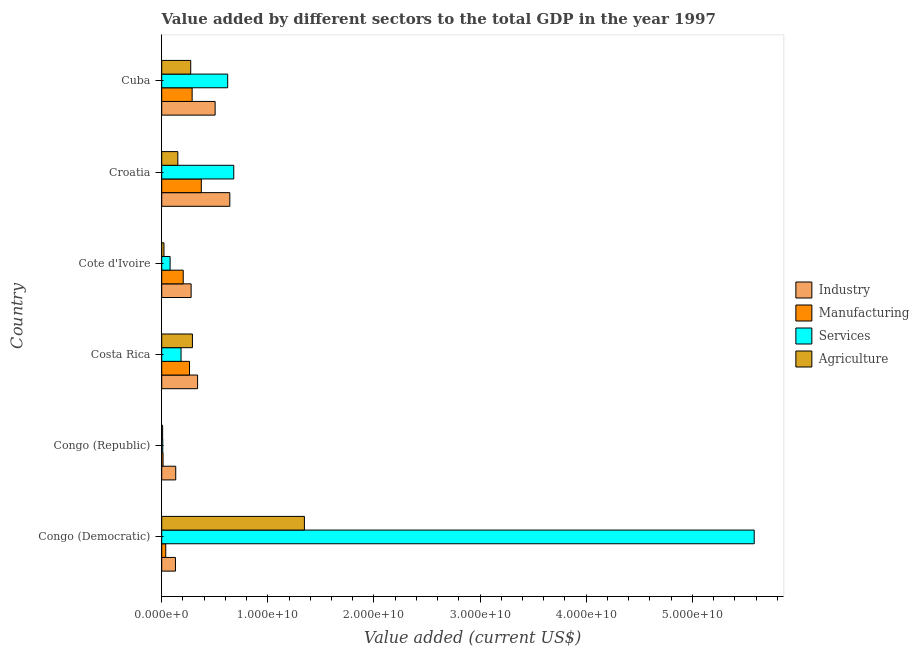How many groups of bars are there?
Give a very brief answer. 6. Are the number of bars per tick equal to the number of legend labels?
Make the answer very short. Yes. What is the label of the 2nd group of bars from the top?
Make the answer very short. Croatia. What is the value added by agricultural sector in Costa Rica?
Your answer should be compact. 2.89e+09. Across all countries, what is the maximum value added by agricultural sector?
Your response must be concise. 1.34e+1. Across all countries, what is the minimum value added by manufacturing sector?
Give a very brief answer. 1.27e+08. In which country was the value added by services sector maximum?
Give a very brief answer. Congo (Democratic). In which country was the value added by agricultural sector minimum?
Offer a terse response. Congo (Republic). What is the total value added by agricultural sector in the graph?
Make the answer very short. 2.09e+1. What is the difference between the value added by services sector in Congo (Republic) and that in Cuba?
Your answer should be compact. -6.12e+09. What is the difference between the value added by agricultural sector in Congo (Democratic) and the value added by manufacturing sector in Congo (Republic)?
Make the answer very short. 1.33e+1. What is the average value added by manufacturing sector per country?
Your response must be concise. 1.96e+09. What is the difference between the value added by agricultural sector and value added by services sector in Congo (Democratic)?
Your response must be concise. -4.24e+1. What is the ratio of the value added by industrial sector in Congo (Democratic) to that in Costa Rica?
Make the answer very short. 0.38. Is the value added by manufacturing sector in Congo (Democratic) less than that in Costa Rica?
Offer a terse response. Yes. Is the difference between the value added by industrial sector in Congo (Democratic) and Cuba greater than the difference between the value added by services sector in Congo (Democratic) and Cuba?
Keep it short and to the point. No. What is the difference between the highest and the second highest value added by industrial sector?
Make the answer very short. 1.38e+09. What is the difference between the highest and the lowest value added by agricultural sector?
Provide a succinct answer. 1.34e+1. In how many countries, is the value added by services sector greater than the average value added by services sector taken over all countries?
Provide a short and direct response. 1. Is the sum of the value added by services sector in Congo (Democratic) and Cote d'Ivoire greater than the maximum value added by manufacturing sector across all countries?
Provide a short and direct response. Yes. Is it the case that in every country, the sum of the value added by services sector and value added by agricultural sector is greater than the sum of value added by manufacturing sector and value added by industrial sector?
Keep it short and to the point. No. What does the 2nd bar from the top in Cote d'Ivoire represents?
Your answer should be compact. Services. What does the 3rd bar from the bottom in Costa Rica represents?
Give a very brief answer. Services. Does the graph contain any zero values?
Offer a very short reply. No. Does the graph contain grids?
Offer a terse response. No. Where does the legend appear in the graph?
Keep it short and to the point. Center right. What is the title of the graph?
Provide a short and direct response. Value added by different sectors to the total GDP in the year 1997. What is the label or title of the X-axis?
Your response must be concise. Value added (current US$). What is the Value added (current US$) of Industry in Congo (Democratic)?
Ensure brevity in your answer.  1.29e+09. What is the Value added (current US$) in Manufacturing in Congo (Democratic)?
Your answer should be very brief. 3.81e+08. What is the Value added (current US$) of Services in Congo (Democratic)?
Your answer should be very brief. 5.58e+1. What is the Value added (current US$) of Agriculture in Congo (Democratic)?
Keep it short and to the point. 1.34e+1. What is the Value added (current US$) of Industry in Congo (Republic)?
Keep it short and to the point. 1.32e+09. What is the Value added (current US$) in Manufacturing in Congo (Republic)?
Give a very brief answer. 1.27e+08. What is the Value added (current US$) in Services in Congo (Republic)?
Your answer should be very brief. 1.00e+08. What is the Value added (current US$) in Agriculture in Congo (Republic)?
Your answer should be compact. 8.67e+07. What is the Value added (current US$) of Industry in Costa Rica?
Keep it short and to the point. 3.38e+09. What is the Value added (current US$) in Manufacturing in Costa Rica?
Ensure brevity in your answer.  2.62e+09. What is the Value added (current US$) of Services in Costa Rica?
Offer a terse response. 1.82e+09. What is the Value added (current US$) of Agriculture in Costa Rica?
Give a very brief answer. 2.89e+09. What is the Value added (current US$) in Industry in Cote d'Ivoire?
Ensure brevity in your answer.  2.77e+09. What is the Value added (current US$) of Manufacturing in Cote d'Ivoire?
Your answer should be compact. 2.03e+09. What is the Value added (current US$) in Services in Cote d'Ivoire?
Your response must be concise. 7.90e+08. What is the Value added (current US$) in Agriculture in Cote d'Ivoire?
Provide a short and direct response. 2.12e+08. What is the Value added (current US$) of Industry in Croatia?
Offer a very short reply. 6.42e+09. What is the Value added (current US$) in Manufacturing in Croatia?
Your answer should be very brief. 3.73e+09. What is the Value added (current US$) in Services in Croatia?
Ensure brevity in your answer.  6.79e+09. What is the Value added (current US$) in Agriculture in Croatia?
Offer a very short reply. 1.52e+09. What is the Value added (current US$) in Industry in Cuba?
Make the answer very short. 5.03e+09. What is the Value added (current US$) in Manufacturing in Cuba?
Your answer should be compact. 2.87e+09. What is the Value added (current US$) in Services in Cuba?
Your answer should be compact. 6.22e+09. What is the Value added (current US$) of Agriculture in Cuba?
Keep it short and to the point. 2.73e+09. Across all countries, what is the maximum Value added (current US$) in Industry?
Give a very brief answer. 6.42e+09. Across all countries, what is the maximum Value added (current US$) of Manufacturing?
Offer a terse response. 3.73e+09. Across all countries, what is the maximum Value added (current US$) in Services?
Ensure brevity in your answer.  5.58e+1. Across all countries, what is the maximum Value added (current US$) in Agriculture?
Provide a succinct answer. 1.34e+1. Across all countries, what is the minimum Value added (current US$) of Industry?
Provide a succinct answer. 1.29e+09. Across all countries, what is the minimum Value added (current US$) of Manufacturing?
Provide a short and direct response. 1.27e+08. Across all countries, what is the minimum Value added (current US$) of Services?
Provide a succinct answer. 1.00e+08. Across all countries, what is the minimum Value added (current US$) in Agriculture?
Provide a short and direct response. 8.67e+07. What is the total Value added (current US$) in Industry in the graph?
Give a very brief answer. 2.02e+1. What is the total Value added (current US$) in Manufacturing in the graph?
Keep it short and to the point. 1.18e+1. What is the total Value added (current US$) of Services in the graph?
Provide a short and direct response. 7.15e+1. What is the total Value added (current US$) in Agriculture in the graph?
Your answer should be very brief. 2.09e+1. What is the difference between the Value added (current US$) in Industry in Congo (Democratic) and that in Congo (Republic)?
Keep it short and to the point. -2.64e+07. What is the difference between the Value added (current US$) of Manufacturing in Congo (Democratic) and that in Congo (Republic)?
Keep it short and to the point. 2.54e+08. What is the difference between the Value added (current US$) in Services in Congo (Democratic) and that in Congo (Republic)?
Provide a succinct answer. 5.57e+1. What is the difference between the Value added (current US$) in Agriculture in Congo (Democratic) and that in Congo (Republic)?
Your response must be concise. 1.34e+1. What is the difference between the Value added (current US$) of Industry in Congo (Democratic) and that in Costa Rica?
Give a very brief answer. -2.09e+09. What is the difference between the Value added (current US$) in Manufacturing in Congo (Democratic) and that in Costa Rica?
Provide a succinct answer. -2.24e+09. What is the difference between the Value added (current US$) in Services in Congo (Democratic) and that in Costa Rica?
Your answer should be compact. 5.40e+1. What is the difference between the Value added (current US$) of Agriculture in Congo (Democratic) and that in Costa Rica?
Ensure brevity in your answer.  1.06e+1. What is the difference between the Value added (current US$) of Industry in Congo (Democratic) and that in Cote d'Ivoire?
Provide a short and direct response. -1.48e+09. What is the difference between the Value added (current US$) in Manufacturing in Congo (Democratic) and that in Cote d'Ivoire?
Your answer should be very brief. -1.65e+09. What is the difference between the Value added (current US$) in Services in Congo (Democratic) and that in Cote d'Ivoire?
Your answer should be very brief. 5.50e+1. What is the difference between the Value added (current US$) of Agriculture in Congo (Democratic) and that in Cote d'Ivoire?
Your response must be concise. 1.32e+1. What is the difference between the Value added (current US$) in Industry in Congo (Democratic) and that in Croatia?
Your response must be concise. -5.12e+09. What is the difference between the Value added (current US$) of Manufacturing in Congo (Democratic) and that in Croatia?
Offer a terse response. -3.35e+09. What is the difference between the Value added (current US$) of Services in Congo (Democratic) and that in Croatia?
Ensure brevity in your answer.  4.90e+1. What is the difference between the Value added (current US$) of Agriculture in Congo (Democratic) and that in Croatia?
Provide a succinct answer. 1.19e+1. What is the difference between the Value added (current US$) in Industry in Congo (Democratic) and that in Cuba?
Keep it short and to the point. -3.74e+09. What is the difference between the Value added (current US$) in Manufacturing in Congo (Democratic) and that in Cuba?
Keep it short and to the point. -2.49e+09. What is the difference between the Value added (current US$) of Services in Congo (Democratic) and that in Cuba?
Provide a short and direct response. 4.96e+1. What is the difference between the Value added (current US$) of Agriculture in Congo (Democratic) and that in Cuba?
Keep it short and to the point. 1.07e+1. What is the difference between the Value added (current US$) of Industry in Congo (Republic) and that in Costa Rica?
Offer a very short reply. -2.06e+09. What is the difference between the Value added (current US$) in Manufacturing in Congo (Republic) and that in Costa Rica?
Offer a terse response. -2.49e+09. What is the difference between the Value added (current US$) in Services in Congo (Republic) and that in Costa Rica?
Ensure brevity in your answer.  -1.72e+09. What is the difference between the Value added (current US$) in Agriculture in Congo (Republic) and that in Costa Rica?
Your answer should be very brief. -2.81e+09. What is the difference between the Value added (current US$) in Industry in Congo (Republic) and that in Cote d'Ivoire?
Make the answer very short. -1.45e+09. What is the difference between the Value added (current US$) of Manufacturing in Congo (Republic) and that in Cote d'Ivoire?
Your answer should be very brief. -1.90e+09. What is the difference between the Value added (current US$) in Services in Congo (Republic) and that in Cote d'Ivoire?
Offer a terse response. -6.90e+08. What is the difference between the Value added (current US$) in Agriculture in Congo (Republic) and that in Cote d'Ivoire?
Offer a very short reply. -1.26e+08. What is the difference between the Value added (current US$) in Industry in Congo (Republic) and that in Croatia?
Your answer should be very brief. -5.10e+09. What is the difference between the Value added (current US$) in Manufacturing in Congo (Republic) and that in Croatia?
Your answer should be very brief. -3.61e+09. What is the difference between the Value added (current US$) in Services in Congo (Republic) and that in Croatia?
Offer a terse response. -6.69e+09. What is the difference between the Value added (current US$) of Agriculture in Congo (Republic) and that in Croatia?
Offer a terse response. -1.43e+09. What is the difference between the Value added (current US$) of Industry in Congo (Republic) and that in Cuba?
Your answer should be very brief. -3.71e+09. What is the difference between the Value added (current US$) of Manufacturing in Congo (Republic) and that in Cuba?
Make the answer very short. -2.74e+09. What is the difference between the Value added (current US$) in Services in Congo (Republic) and that in Cuba?
Offer a terse response. -6.12e+09. What is the difference between the Value added (current US$) of Agriculture in Congo (Republic) and that in Cuba?
Make the answer very short. -2.65e+09. What is the difference between the Value added (current US$) of Industry in Costa Rica and that in Cote d'Ivoire?
Give a very brief answer. 6.10e+08. What is the difference between the Value added (current US$) of Manufacturing in Costa Rica and that in Cote d'Ivoire?
Ensure brevity in your answer.  5.92e+08. What is the difference between the Value added (current US$) in Services in Costa Rica and that in Cote d'Ivoire?
Make the answer very short. 1.03e+09. What is the difference between the Value added (current US$) of Agriculture in Costa Rica and that in Cote d'Ivoire?
Your answer should be compact. 2.68e+09. What is the difference between the Value added (current US$) of Industry in Costa Rica and that in Croatia?
Give a very brief answer. -3.04e+09. What is the difference between the Value added (current US$) of Manufacturing in Costa Rica and that in Croatia?
Your response must be concise. -1.11e+09. What is the difference between the Value added (current US$) in Services in Costa Rica and that in Croatia?
Your answer should be very brief. -4.97e+09. What is the difference between the Value added (current US$) of Agriculture in Costa Rica and that in Croatia?
Offer a terse response. 1.37e+09. What is the difference between the Value added (current US$) in Industry in Costa Rica and that in Cuba?
Your response must be concise. -1.65e+09. What is the difference between the Value added (current US$) in Manufacturing in Costa Rica and that in Cuba?
Offer a terse response. -2.49e+08. What is the difference between the Value added (current US$) of Services in Costa Rica and that in Cuba?
Provide a succinct answer. -4.39e+09. What is the difference between the Value added (current US$) in Agriculture in Costa Rica and that in Cuba?
Your response must be concise. 1.60e+08. What is the difference between the Value added (current US$) of Industry in Cote d'Ivoire and that in Croatia?
Your response must be concise. -3.64e+09. What is the difference between the Value added (current US$) in Manufacturing in Cote d'Ivoire and that in Croatia?
Your response must be concise. -1.71e+09. What is the difference between the Value added (current US$) of Services in Cote d'Ivoire and that in Croatia?
Provide a short and direct response. -6.00e+09. What is the difference between the Value added (current US$) of Agriculture in Cote d'Ivoire and that in Croatia?
Your answer should be compact. -1.31e+09. What is the difference between the Value added (current US$) of Industry in Cote d'Ivoire and that in Cuba?
Keep it short and to the point. -2.26e+09. What is the difference between the Value added (current US$) in Manufacturing in Cote d'Ivoire and that in Cuba?
Offer a very short reply. -8.41e+08. What is the difference between the Value added (current US$) of Services in Cote d'Ivoire and that in Cuba?
Your response must be concise. -5.43e+09. What is the difference between the Value added (current US$) of Agriculture in Cote d'Ivoire and that in Cuba?
Make the answer very short. -2.52e+09. What is the difference between the Value added (current US$) of Industry in Croatia and that in Cuba?
Offer a very short reply. 1.38e+09. What is the difference between the Value added (current US$) of Manufacturing in Croatia and that in Cuba?
Keep it short and to the point. 8.65e+08. What is the difference between the Value added (current US$) in Services in Croatia and that in Cuba?
Give a very brief answer. 5.73e+08. What is the difference between the Value added (current US$) in Agriculture in Croatia and that in Cuba?
Your answer should be compact. -1.21e+09. What is the difference between the Value added (current US$) of Industry in Congo (Democratic) and the Value added (current US$) of Manufacturing in Congo (Republic)?
Provide a succinct answer. 1.17e+09. What is the difference between the Value added (current US$) of Industry in Congo (Democratic) and the Value added (current US$) of Services in Congo (Republic)?
Your answer should be very brief. 1.19e+09. What is the difference between the Value added (current US$) of Industry in Congo (Democratic) and the Value added (current US$) of Agriculture in Congo (Republic)?
Provide a short and direct response. 1.21e+09. What is the difference between the Value added (current US$) of Manufacturing in Congo (Democratic) and the Value added (current US$) of Services in Congo (Republic)?
Ensure brevity in your answer.  2.81e+08. What is the difference between the Value added (current US$) of Manufacturing in Congo (Democratic) and the Value added (current US$) of Agriculture in Congo (Republic)?
Your answer should be compact. 2.94e+08. What is the difference between the Value added (current US$) of Services in Congo (Democratic) and the Value added (current US$) of Agriculture in Congo (Republic)?
Your response must be concise. 5.57e+1. What is the difference between the Value added (current US$) of Industry in Congo (Democratic) and the Value added (current US$) of Manufacturing in Costa Rica?
Make the answer very short. -1.32e+09. What is the difference between the Value added (current US$) of Industry in Congo (Democratic) and the Value added (current US$) of Services in Costa Rica?
Make the answer very short. -5.28e+08. What is the difference between the Value added (current US$) in Industry in Congo (Democratic) and the Value added (current US$) in Agriculture in Costa Rica?
Offer a very short reply. -1.60e+09. What is the difference between the Value added (current US$) in Manufacturing in Congo (Democratic) and the Value added (current US$) in Services in Costa Rica?
Your answer should be very brief. -1.44e+09. What is the difference between the Value added (current US$) of Manufacturing in Congo (Democratic) and the Value added (current US$) of Agriculture in Costa Rica?
Provide a short and direct response. -2.51e+09. What is the difference between the Value added (current US$) in Services in Congo (Democratic) and the Value added (current US$) in Agriculture in Costa Rica?
Keep it short and to the point. 5.29e+1. What is the difference between the Value added (current US$) in Industry in Congo (Democratic) and the Value added (current US$) in Manufacturing in Cote d'Ivoire?
Your answer should be compact. -7.32e+08. What is the difference between the Value added (current US$) in Industry in Congo (Democratic) and the Value added (current US$) in Services in Cote d'Ivoire?
Provide a succinct answer. 5.05e+08. What is the difference between the Value added (current US$) in Industry in Congo (Democratic) and the Value added (current US$) in Agriculture in Cote d'Ivoire?
Offer a very short reply. 1.08e+09. What is the difference between the Value added (current US$) in Manufacturing in Congo (Democratic) and the Value added (current US$) in Services in Cote d'Ivoire?
Your answer should be compact. -4.09e+08. What is the difference between the Value added (current US$) in Manufacturing in Congo (Democratic) and the Value added (current US$) in Agriculture in Cote d'Ivoire?
Your answer should be compact. 1.68e+08. What is the difference between the Value added (current US$) in Services in Congo (Democratic) and the Value added (current US$) in Agriculture in Cote d'Ivoire?
Provide a short and direct response. 5.56e+1. What is the difference between the Value added (current US$) in Industry in Congo (Democratic) and the Value added (current US$) in Manufacturing in Croatia?
Offer a very short reply. -2.44e+09. What is the difference between the Value added (current US$) of Industry in Congo (Democratic) and the Value added (current US$) of Services in Croatia?
Provide a short and direct response. -5.50e+09. What is the difference between the Value added (current US$) of Industry in Congo (Democratic) and the Value added (current US$) of Agriculture in Croatia?
Your answer should be very brief. -2.24e+08. What is the difference between the Value added (current US$) of Manufacturing in Congo (Democratic) and the Value added (current US$) of Services in Croatia?
Offer a very short reply. -6.41e+09. What is the difference between the Value added (current US$) in Manufacturing in Congo (Democratic) and the Value added (current US$) in Agriculture in Croatia?
Offer a terse response. -1.14e+09. What is the difference between the Value added (current US$) of Services in Congo (Democratic) and the Value added (current US$) of Agriculture in Croatia?
Offer a very short reply. 5.43e+1. What is the difference between the Value added (current US$) in Industry in Congo (Democratic) and the Value added (current US$) in Manufacturing in Cuba?
Provide a short and direct response. -1.57e+09. What is the difference between the Value added (current US$) of Industry in Congo (Democratic) and the Value added (current US$) of Services in Cuba?
Keep it short and to the point. -4.92e+09. What is the difference between the Value added (current US$) of Industry in Congo (Democratic) and the Value added (current US$) of Agriculture in Cuba?
Provide a succinct answer. -1.44e+09. What is the difference between the Value added (current US$) in Manufacturing in Congo (Democratic) and the Value added (current US$) in Services in Cuba?
Provide a short and direct response. -5.84e+09. What is the difference between the Value added (current US$) in Manufacturing in Congo (Democratic) and the Value added (current US$) in Agriculture in Cuba?
Keep it short and to the point. -2.35e+09. What is the difference between the Value added (current US$) in Services in Congo (Democratic) and the Value added (current US$) in Agriculture in Cuba?
Keep it short and to the point. 5.31e+1. What is the difference between the Value added (current US$) of Industry in Congo (Republic) and the Value added (current US$) of Manufacturing in Costa Rica?
Provide a short and direct response. -1.30e+09. What is the difference between the Value added (current US$) of Industry in Congo (Republic) and the Value added (current US$) of Services in Costa Rica?
Give a very brief answer. -5.02e+08. What is the difference between the Value added (current US$) of Industry in Congo (Republic) and the Value added (current US$) of Agriculture in Costa Rica?
Your response must be concise. -1.57e+09. What is the difference between the Value added (current US$) of Manufacturing in Congo (Republic) and the Value added (current US$) of Services in Costa Rica?
Make the answer very short. -1.70e+09. What is the difference between the Value added (current US$) of Manufacturing in Congo (Republic) and the Value added (current US$) of Agriculture in Costa Rica?
Give a very brief answer. -2.77e+09. What is the difference between the Value added (current US$) in Services in Congo (Republic) and the Value added (current US$) in Agriculture in Costa Rica?
Keep it short and to the point. -2.79e+09. What is the difference between the Value added (current US$) in Industry in Congo (Republic) and the Value added (current US$) in Manufacturing in Cote d'Ivoire?
Offer a terse response. -7.05e+08. What is the difference between the Value added (current US$) in Industry in Congo (Republic) and the Value added (current US$) in Services in Cote d'Ivoire?
Your response must be concise. 5.31e+08. What is the difference between the Value added (current US$) of Industry in Congo (Republic) and the Value added (current US$) of Agriculture in Cote d'Ivoire?
Offer a very short reply. 1.11e+09. What is the difference between the Value added (current US$) of Manufacturing in Congo (Republic) and the Value added (current US$) of Services in Cote d'Ivoire?
Make the answer very short. -6.63e+08. What is the difference between the Value added (current US$) in Manufacturing in Congo (Republic) and the Value added (current US$) in Agriculture in Cote d'Ivoire?
Your response must be concise. -8.55e+07. What is the difference between the Value added (current US$) of Services in Congo (Republic) and the Value added (current US$) of Agriculture in Cote d'Ivoire?
Your answer should be compact. -1.12e+08. What is the difference between the Value added (current US$) of Industry in Congo (Republic) and the Value added (current US$) of Manufacturing in Croatia?
Your answer should be very brief. -2.41e+09. What is the difference between the Value added (current US$) in Industry in Congo (Republic) and the Value added (current US$) in Services in Croatia?
Keep it short and to the point. -5.47e+09. What is the difference between the Value added (current US$) in Industry in Congo (Republic) and the Value added (current US$) in Agriculture in Croatia?
Ensure brevity in your answer.  -1.98e+08. What is the difference between the Value added (current US$) of Manufacturing in Congo (Republic) and the Value added (current US$) of Services in Croatia?
Offer a terse response. -6.66e+09. What is the difference between the Value added (current US$) of Manufacturing in Congo (Republic) and the Value added (current US$) of Agriculture in Croatia?
Your answer should be compact. -1.39e+09. What is the difference between the Value added (current US$) of Services in Congo (Republic) and the Value added (current US$) of Agriculture in Croatia?
Provide a short and direct response. -1.42e+09. What is the difference between the Value added (current US$) of Industry in Congo (Republic) and the Value added (current US$) of Manufacturing in Cuba?
Your answer should be compact. -1.55e+09. What is the difference between the Value added (current US$) of Industry in Congo (Republic) and the Value added (current US$) of Services in Cuba?
Make the answer very short. -4.90e+09. What is the difference between the Value added (current US$) of Industry in Congo (Republic) and the Value added (current US$) of Agriculture in Cuba?
Your response must be concise. -1.41e+09. What is the difference between the Value added (current US$) in Manufacturing in Congo (Republic) and the Value added (current US$) in Services in Cuba?
Offer a very short reply. -6.09e+09. What is the difference between the Value added (current US$) of Manufacturing in Congo (Republic) and the Value added (current US$) of Agriculture in Cuba?
Offer a terse response. -2.61e+09. What is the difference between the Value added (current US$) in Services in Congo (Republic) and the Value added (current US$) in Agriculture in Cuba?
Offer a terse response. -2.63e+09. What is the difference between the Value added (current US$) of Industry in Costa Rica and the Value added (current US$) of Manufacturing in Cote d'Ivoire?
Provide a short and direct response. 1.36e+09. What is the difference between the Value added (current US$) in Industry in Costa Rica and the Value added (current US$) in Services in Cote d'Ivoire?
Give a very brief answer. 2.59e+09. What is the difference between the Value added (current US$) of Industry in Costa Rica and the Value added (current US$) of Agriculture in Cote d'Ivoire?
Provide a short and direct response. 3.17e+09. What is the difference between the Value added (current US$) of Manufacturing in Costa Rica and the Value added (current US$) of Services in Cote d'Ivoire?
Ensure brevity in your answer.  1.83e+09. What is the difference between the Value added (current US$) of Manufacturing in Costa Rica and the Value added (current US$) of Agriculture in Cote d'Ivoire?
Provide a succinct answer. 2.41e+09. What is the difference between the Value added (current US$) in Services in Costa Rica and the Value added (current US$) in Agriculture in Cote d'Ivoire?
Your response must be concise. 1.61e+09. What is the difference between the Value added (current US$) in Industry in Costa Rica and the Value added (current US$) in Manufacturing in Croatia?
Ensure brevity in your answer.  -3.50e+08. What is the difference between the Value added (current US$) in Industry in Costa Rica and the Value added (current US$) in Services in Croatia?
Give a very brief answer. -3.41e+09. What is the difference between the Value added (current US$) in Industry in Costa Rica and the Value added (current US$) in Agriculture in Croatia?
Ensure brevity in your answer.  1.86e+09. What is the difference between the Value added (current US$) in Manufacturing in Costa Rica and the Value added (current US$) in Services in Croatia?
Give a very brief answer. -4.17e+09. What is the difference between the Value added (current US$) of Manufacturing in Costa Rica and the Value added (current US$) of Agriculture in Croatia?
Make the answer very short. 1.10e+09. What is the difference between the Value added (current US$) in Services in Costa Rica and the Value added (current US$) in Agriculture in Croatia?
Provide a succinct answer. 3.04e+08. What is the difference between the Value added (current US$) of Industry in Costa Rica and the Value added (current US$) of Manufacturing in Cuba?
Make the answer very short. 5.15e+08. What is the difference between the Value added (current US$) of Industry in Costa Rica and the Value added (current US$) of Services in Cuba?
Give a very brief answer. -2.83e+09. What is the difference between the Value added (current US$) of Industry in Costa Rica and the Value added (current US$) of Agriculture in Cuba?
Your answer should be very brief. 6.48e+08. What is the difference between the Value added (current US$) of Manufacturing in Costa Rica and the Value added (current US$) of Services in Cuba?
Provide a succinct answer. -3.60e+09. What is the difference between the Value added (current US$) of Manufacturing in Costa Rica and the Value added (current US$) of Agriculture in Cuba?
Make the answer very short. -1.16e+08. What is the difference between the Value added (current US$) of Services in Costa Rica and the Value added (current US$) of Agriculture in Cuba?
Ensure brevity in your answer.  -9.11e+08. What is the difference between the Value added (current US$) in Industry in Cote d'Ivoire and the Value added (current US$) in Manufacturing in Croatia?
Ensure brevity in your answer.  -9.60e+08. What is the difference between the Value added (current US$) of Industry in Cote d'Ivoire and the Value added (current US$) of Services in Croatia?
Ensure brevity in your answer.  -4.02e+09. What is the difference between the Value added (current US$) of Industry in Cote d'Ivoire and the Value added (current US$) of Agriculture in Croatia?
Your answer should be very brief. 1.25e+09. What is the difference between the Value added (current US$) of Manufacturing in Cote d'Ivoire and the Value added (current US$) of Services in Croatia?
Provide a succinct answer. -4.76e+09. What is the difference between the Value added (current US$) of Manufacturing in Cote d'Ivoire and the Value added (current US$) of Agriculture in Croatia?
Offer a terse response. 5.07e+08. What is the difference between the Value added (current US$) in Services in Cote d'Ivoire and the Value added (current US$) in Agriculture in Croatia?
Your response must be concise. -7.29e+08. What is the difference between the Value added (current US$) in Industry in Cote d'Ivoire and the Value added (current US$) in Manufacturing in Cuba?
Keep it short and to the point. -9.50e+07. What is the difference between the Value added (current US$) in Industry in Cote d'Ivoire and the Value added (current US$) in Services in Cuba?
Keep it short and to the point. -3.44e+09. What is the difference between the Value added (current US$) in Industry in Cote d'Ivoire and the Value added (current US$) in Agriculture in Cuba?
Offer a very short reply. 3.88e+07. What is the difference between the Value added (current US$) of Manufacturing in Cote d'Ivoire and the Value added (current US$) of Services in Cuba?
Provide a succinct answer. -4.19e+09. What is the difference between the Value added (current US$) in Manufacturing in Cote d'Ivoire and the Value added (current US$) in Agriculture in Cuba?
Ensure brevity in your answer.  -7.07e+08. What is the difference between the Value added (current US$) of Services in Cote d'Ivoire and the Value added (current US$) of Agriculture in Cuba?
Keep it short and to the point. -1.94e+09. What is the difference between the Value added (current US$) of Industry in Croatia and the Value added (current US$) of Manufacturing in Cuba?
Ensure brevity in your answer.  3.55e+09. What is the difference between the Value added (current US$) in Industry in Croatia and the Value added (current US$) in Services in Cuba?
Give a very brief answer. 2.01e+08. What is the difference between the Value added (current US$) in Industry in Croatia and the Value added (current US$) in Agriculture in Cuba?
Offer a terse response. 3.68e+09. What is the difference between the Value added (current US$) in Manufacturing in Croatia and the Value added (current US$) in Services in Cuba?
Make the answer very short. -2.48e+09. What is the difference between the Value added (current US$) in Manufacturing in Croatia and the Value added (current US$) in Agriculture in Cuba?
Make the answer very short. 9.99e+08. What is the difference between the Value added (current US$) in Services in Croatia and the Value added (current US$) in Agriculture in Cuba?
Provide a succinct answer. 4.06e+09. What is the average Value added (current US$) in Industry per country?
Your answer should be compact. 3.37e+09. What is the average Value added (current US$) in Manufacturing per country?
Provide a succinct answer. 1.96e+09. What is the average Value added (current US$) in Services per country?
Your answer should be very brief. 1.19e+1. What is the average Value added (current US$) of Agriculture per country?
Your response must be concise. 3.48e+09. What is the difference between the Value added (current US$) in Industry and Value added (current US$) in Manufacturing in Congo (Democratic)?
Your answer should be very brief. 9.14e+08. What is the difference between the Value added (current US$) of Industry and Value added (current US$) of Services in Congo (Democratic)?
Keep it short and to the point. -5.45e+1. What is the difference between the Value added (current US$) in Industry and Value added (current US$) in Agriculture in Congo (Democratic)?
Your answer should be very brief. -1.22e+1. What is the difference between the Value added (current US$) in Manufacturing and Value added (current US$) in Services in Congo (Democratic)?
Keep it short and to the point. -5.55e+1. What is the difference between the Value added (current US$) of Manufacturing and Value added (current US$) of Agriculture in Congo (Democratic)?
Your response must be concise. -1.31e+1. What is the difference between the Value added (current US$) of Services and Value added (current US$) of Agriculture in Congo (Democratic)?
Provide a succinct answer. 4.24e+1. What is the difference between the Value added (current US$) in Industry and Value added (current US$) in Manufacturing in Congo (Republic)?
Give a very brief answer. 1.19e+09. What is the difference between the Value added (current US$) in Industry and Value added (current US$) in Services in Congo (Republic)?
Offer a terse response. 1.22e+09. What is the difference between the Value added (current US$) in Industry and Value added (current US$) in Agriculture in Congo (Republic)?
Offer a very short reply. 1.23e+09. What is the difference between the Value added (current US$) of Manufacturing and Value added (current US$) of Services in Congo (Republic)?
Your response must be concise. 2.67e+07. What is the difference between the Value added (current US$) in Manufacturing and Value added (current US$) in Agriculture in Congo (Republic)?
Ensure brevity in your answer.  4.00e+07. What is the difference between the Value added (current US$) in Services and Value added (current US$) in Agriculture in Congo (Republic)?
Give a very brief answer. 1.33e+07. What is the difference between the Value added (current US$) of Industry and Value added (current US$) of Manufacturing in Costa Rica?
Make the answer very short. 7.64e+08. What is the difference between the Value added (current US$) in Industry and Value added (current US$) in Services in Costa Rica?
Your answer should be compact. 1.56e+09. What is the difference between the Value added (current US$) in Industry and Value added (current US$) in Agriculture in Costa Rica?
Offer a very short reply. 4.89e+08. What is the difference between the Value added (current US$) in Manufacturing and Value added (current US$) in Services in Costa Rica?
Give a very brief answer. 7.95e+08. What is the difference between the Value added (current US$) in Manufacturing and Value added (current US$) in Agriculture in Costa Rica?
Offer a very short reply. -2.75e+08. What is the difference between the Value added (current US$) of Services and Value added (current US$) of Agriculture in Costa Rica?
Make the answer very short. -1.07e+09. What is the difference between the Value added (current US$) of Industry and Value added (current US$) of Manufacturing in Cote d'Ivoire?
Provide a short and direct response. 7.46e+08. What is the difference between the Value added (current US$) of Industry and Value added (current US$) of Services in Cote d'Ivoire?
Ensure brevity in your answer.  1.98e+09. What is the difference between the Value added (current US$) of Industry and Value added (current US$) of Agriculture in Cote d'Ivoire?
Your response must be concise. 2.56e+09. What is the difference between the Value added (current US$) in Manufacturing and Value added (current US$) in Services in Cote d'Ivoire?
Give a very brief answer. 1.24e+09. What is the difference between the Value added (current US$) of Manufacturing and Value added (current US$) of Agriculture in Cote d'Ivoire?
Provide a succinct answer. 1.81e+09. What is the difference between the Value added (current US$) in Services and Value added (current US$) in Agriculture in Cote d'Ivoire?
Ensure brevity in your answer.  5.77e+08. What is the difference between the Value added (current US$) of Industry and Value added (current US$) of Manufacturing in Croatia?
Give a very brief answer. 2.68e+09. What is the difference between the Value added (current US$) in Industry and Value added (current US$) in Services in Croatia?
Your answer should be very brief. -3.73e+08. What is the difference between the Value added (current US$) of Industry and Value added (current US$) of Agriculture in Croatia?
Keep it short and to the point. 4.90e+09. What is the difference between the Value added (current US$) in Manufacturing and Value added (current US$) in Services in Croatia?
Make the answer very short. -3.06e+09. What is the difference between the Value added (current US$) in Manufacturing and Value added (current US$) in Agriculture in Croatia?
Your response must be concise. 2.21e+09. What is the difference between the Value added (current US$) of Services and Value added (current US$) of Agriculture in Croatia?
Offer a very short reply. 5.27e+09. What is the difference between the Value added (current US$) of Industry and Value added (current US$) of Manufacturing in Cuba?
Offer a terse response. 2.17e+09. What is the difference between the Value added (current US$) of Industry and Value added (current US$) of Services in Cuba?
Offer a very short reply. -1.18e+09. What is the difference between the Value added (current US$) in Industry and Value added (current US$) in Agriculture in Cuba?
Ensure brevity in your answer.  2.30e+09. What is the difference between the Value added (current US$) of Manufacturing and Value added (current US$) of Services in Cuba?
Give a very brief answer. -3.35e+09. What is the difference between the Value added (current US$) in Manufacturing and Value added (current US$) in Agriculture in Cuba?
Ensure brevity in your answer.  1.34e+08. What is the difference between the Value added (current US$) in Services and Value added (current US$) in Agriculture in Cuba?
Make the answer very short. 3.48e+09. What is the ratio of the Value added (current US$) of Manufacturing in Congo (Democratic) to that in Congo (Republic)?
Offer a very short reply. 3. What is the ratio of the Value added (current US$) of Services in Congo (Democratic) to that in Congo (Republic)?
Provide a short and direct response. 558.11. What is the ratio of the Value added (current US$) of Agriculture in Congo (Democratic) to that in Congo (Republic)?
Your answer should be very brief. 155.02. What is the ratio of the Value added (current US$) in Industry in Congo (Democratic) to that in Costa Rica?
Keep it short and to the point. 0.38. What is the ratio of the Value added (current US$) of Manufacturing in Congo (Democratic) to that in Costa Rica?
Provide a succinct answer. 0.15. What is the ratio of the Value added (current US$) of Services in Congo (Democratic) to that in Costa Rica?
Make the answer very short. 30.63. What is the ratio of the Value added (current US$) in Agriculture in Congo (Democratic) to that in Costa Rica?
Offer a terse response. 4.65. What is the ratio of the Value added (current US$) in Industry in Congo (Democratic) to that in Cote d'Ivoire?
Give a very brief answer. 0.47. What is the ratio of the Value added (current US$) of Manufacturing in Congo (Democratic) to that in Cote d'Ivoire?
Ensure brevity in your answer.  0.19. What is the ratio of the Value added (current US$) of Services in Congo (Democratic) to that in Cote d'Ivoire?
Your response must be concise. 70.7. What is the ratio of the Value added (current US$) in Agriculture in Congo (Democratic) to that in Cote d'Ivoire?
Provide a short and direct response. 63.34. What is the ratio of the Value added (current US$) of Industry in Congo (Democratic) to that in Croatia?
Make the answer very short. 0.2. What is the ratio of the Value added (current US$) in Manufacturing in Congo (Democratic) to that in Croatia?
Offer a terse response. 0.1. What is the ratio of the Value added (current US$) in Services in Congo (Democratic) to that in Croatia?
Your answer should be compact. 8.22. What is the ratio of the Value added (current US$) of Agriculture in Congo (Democratic) to that in Croatia?
Your answer should be very brief. 8.85. What is the ratio of the Value added (current US$) of Industry in Congo (Democratic) to that in Cuba?
Offer a very short reply. 0.26. What is the ratio of the Value added (current US$) of Manufacturing in Congo (Democratic) to that in Cuba?
Make the answer very short. 0.13. What is the ratio of the Value added (current US$) in Services in Congo (Democratic) to that in Cuba?
Your response must be concise. 8.98. What is the ratio of the Value added (current US$) in Agriculture in Congo (Democratic) to that in Cuba?
Provide a succinct answer. 4.92. What is the ratio of the Value added (current US$) in Industry in Congo (Republic) to that in Costa Rica?
Make the answer very short. 0.39. What is the ratio of the Value added (current US$) in Manufacturing in Congo (Republic) to that in Costa Rica?
Your response must be concise. 0.05. What is the ratio of the Value added (current US$) in Services in Congo (Republic) to that in Costa Rica?
Offer a terse response. 0.05. What is the ratio of the Value added (current US$) in Agriculture in Congo (Republic) to that in Costa Rica?
Offer a terse response. 0.03. What is the ratio of the Value added (current US$) of Industry in Congo (Republic) to that in Cote d'Ivoire?
Offer a very short reply. 0.48. What is the ratio of the Value added (current US$) of Manufacturing in Congo (Republic) to that in Cote d'Ivoire?
Your answer should be very brief. 0.06. What is the ratio of the Value added (current US$) of Services in Congo (Republic) to that in Cote d'Ivoire?
Offer a very short reply. 0.13. What is the ratio of the Value added (current US$) in Agriculture in Congo (Republic) to that in Cote d'Ivoire?
Give a very brief answer. 0.41. What is the ratio of the Value added (current US$) in Industry in Congo (Republic) to that in Croatia?
Offer a very short reply. 0.21. What is the ratio of the Value added (current US$) in Manufacturing in Congo (Republic) to that in Croatia?
Provide a short and direct response. 0.03. What is the ratio of the Value added (current US$) in Services in Congo (Republic) to that in Croatia?
Your response must be concise. 0.01. What is the ratio of the Value added (current US$) in Agriculture in Congo (Republic) to that in Croatia?
Your answer should be very brief. 0.06. What is the ratio of the Value added (current US$) in Industry in Congo (Republic) to that in Cuba?
Make the answer very short. 0.26. What is the ratio of the Value added (current US$) in Manufacturing in Congo (Republic) to that in Cuba?
Your answer should be compact. 0.04. What is the ratio of the Value added (current US$) of Services in Congo (Republic) to that in Cuba?
Provide a succinct answer. 0.02. What is the ratio of the Value added (current US$) of Agriculture in Congo (Republic) to that in Cuba?
Provide a succinct answer. 0.03. What is the ratio of the Value added (current US$) of Industry in Costa Rica to that in Cote d'Ivoire?
Provide a short and direct response. 1.22. What is the ratio of the Value added (current US$) of Manufacturing in Costa Rica to that in Cote d'Ivoire?
Your answer should be very brief. 1.29. What is the ratio of the Value added (current US$) in Services in Costa Rica to that in Cote d'Ivoire?
Offer a terse response. 2.31. What is the ratio of the Value added (current US$) in Agriculture in Costa Rica to that in Cote d'Ivoire?
Ensure brevity in your answer.  13.63. What is the ratio of the Value added (current US$) in Industry in Costa Rica to that in Croatia?
Your answer should be very brief. 0.53. What is the ratio of the Value added (current US$) of Manufacturing in Costa Rica to that in Croatia?
Ensure brevity in your answer.  0.7. What is the ratio of the Value added (current US$) of Services in Costa Rica to that in Croatia?
Ensure brevity in your answer.  0.27. What is the ratio of the Value added (current US$) in Agriculture in Costa Rica to that in Croatia?
Your answer should be compact. 1.9. What is the ratio of the Value added (current US$) in Industry in Costa Rica to that in Cuba?
Offer a very short reply. 0.67. What is the ratio of the Value added (current US$) in Services in Costa Rica to that in Cuba?
Offer a terse response. 0.29. What is the ratio of the Value added (current US$) of Agriculture in Costa Rica to that in Cuba?
Keep it short and to the point. 1.06. What is the ratio of the Value added (current US$) of Industry in Cote d'Ivoire to that in Croatia?
Make the answer very short. 0.43. What is the ratio of the Value added (current US$) of Manufacturing in Cote d'Ivoire to that in Croatia?
Keep it short and to the point. 0.54. What is the ratio of the Value added (current US$) in Services in Cote d'Ivoire to that in Croatia?
Your answer should be very brief. 0.12. What is the ratio of the Value added (current US$) of Agriculture in Cote d'Ivoire to that in Croatia?
Offer a very short reply. 0.14. What is the ratio of the Value added (current US$) of Industry in Cote d'Ivoire to that in Cuba?
Your answer should be compact. 0.55. What is the ratio of the Value added (current US$) in Manufacturing in Cote d'Ivoire to that in Cuba?
Ensure brevity in your answer.  0.71. What is the ratio of the Value added (current US$) in Services in Cote d'Ivoire to that in Cuba?
Offer a very short reply. 0.13. What is the ratio of the Value added (current US$) in Agriculture in Cote d'Ivoire to that in Cuba?
Offer a very short reply. 0.08. What is the ratio of the Value added (current US$) in Industry in Croatia to that in Cuba?
Your answer should be very brief. 1.28. What is the ratio of the Value added (current US$) of Manufacturing in Croatia to that in Cuba?
Give a very brief answer. 1.3. What is the ratio of the Value added (current US$) of Services in Croatia to that in Cuba?
Your response must be concise. 1.09. What is the ratio of the Value added (current US$) in Agriculture in Croatia to that in Cuba?
Keep it short and to the point. 0.56. What is the difference between the highest and the second highest Value added (current US$) in Industry?
Make the answer very short. 1.38e+09. What is the difference between the highest and the second highest Value added (current US$) in Manufacturing?
Your answer should be compact. 8.65e+08. What is the difference between the highest and the second highest Value added (current US$) in Services?
Offer a terse response. 4.90e+1. What is the difference between the highest and the second highest Value added (current US$) in Agriculture?
Make the answer very short. 1.06e+1. What is the difference between the highest and the lowest Value added (current US$) of Industry?
Provide a succinct answer. 5.12e+09. What is the difference between the highest and the lowest Value added (current US$) of Manufacturing?
Provide a succinct answer. 3.61e+09. What is the difference between the highest and the lowest Value added (current US$) in Services?
Ensure brevity in your answer.  5.57e+1. What is the difference between the highest and the lowest Value added (current US$) of Agriculture?
Ensure brevity in your answer.  1.34e+1. 